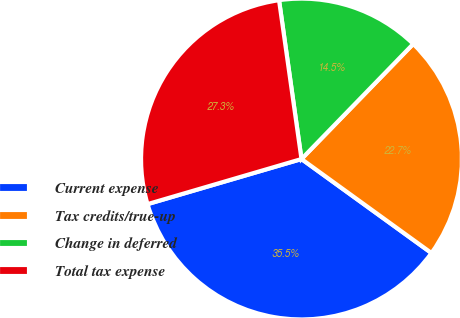<chart> <loc_0><loc_0><loc_500><loc_500><pie_chart><fcel>Current expense<fcel>Tax credits/true-up<fcel>Change in deferred<fcel>Total tax expense<nl><fcel>35.5%<fcel>22.7%<fcel>14.5%<fcel>27.3%<nl></chart> 